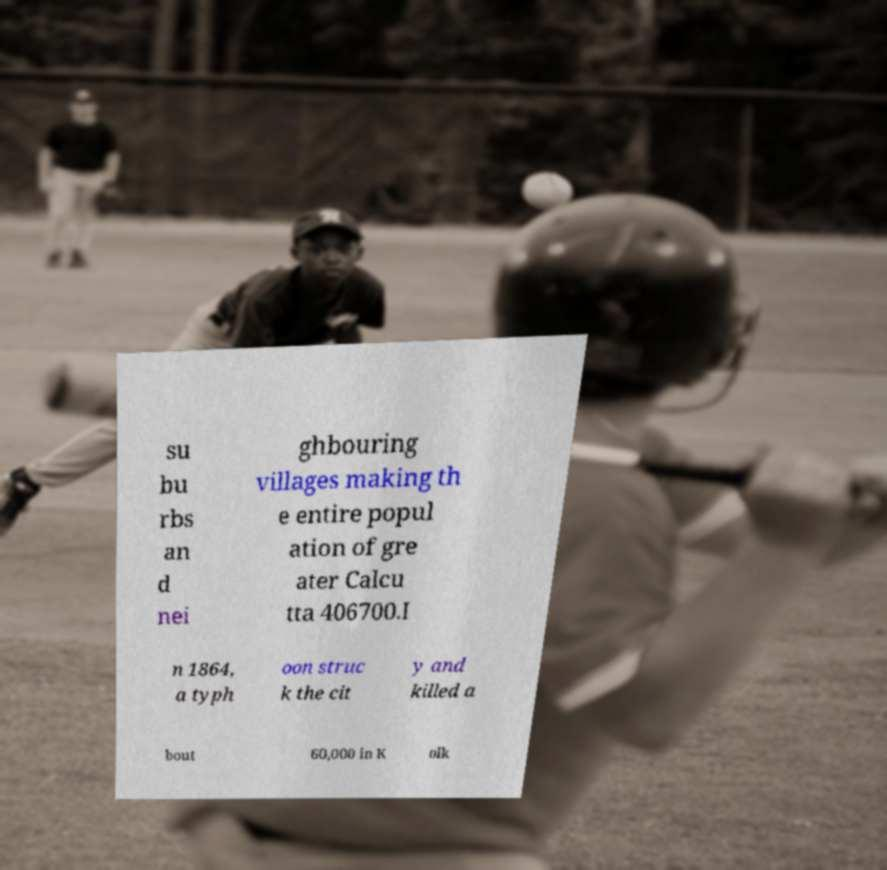For documentation purposes, I need the text within this image transcribed. Could you provide that? su bu rbs an d nei ghbouring villages making th e entire popul ation of gre ater Calcu tta 406700.I n 1864, a typh oon struc k the cit y and killed a bout 60,000 in K olk 